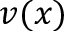<formula> <loc_0><loc_0><loc_500><loc_500>v ( x )</formula> 